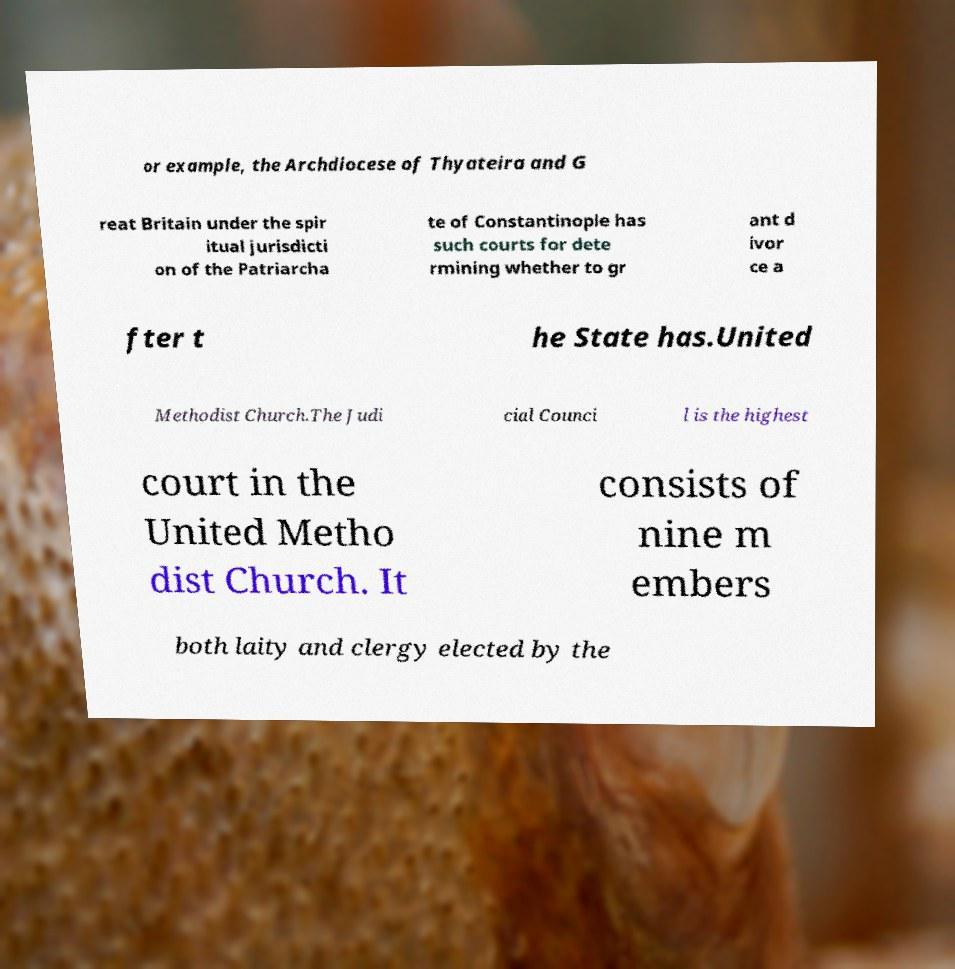Please read and relay the text visible in this image. What does it say? or example, the Archdiocese of Thyateira and G reat Britain under the spir itual jurisdicti on of the Patriarcha te of Constantinople has such courts for dete rmining whether to gr ant d ivor ce a fter t he State has.United Methodist Church.The Judi cial Counci l is the highest court in the United Metho dist Church. It consists of nine m embers both laity and clergy elected by the 